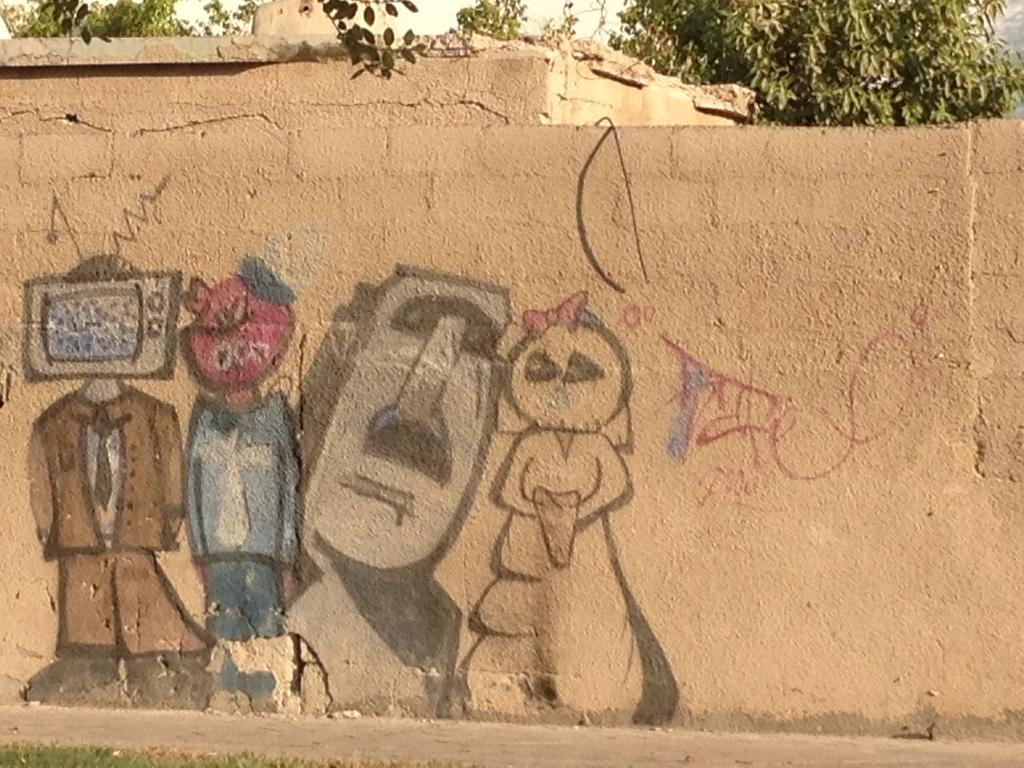What type of surface is visible in front of the image? There is grass on the surface in front of the image. What can be seen on the wall in the image? There is a painting on the wall. What type of vegetation is visible in the background of the image? There are there any trees? What type of amusement park can be seen in the background of the image? There is no amusement park visible in the image; it features trees in the background. What type of poison might be present in the painting on the wall? There is no mention of poison in the image, and the painting on the wall does not suggest any poisonous elements. 